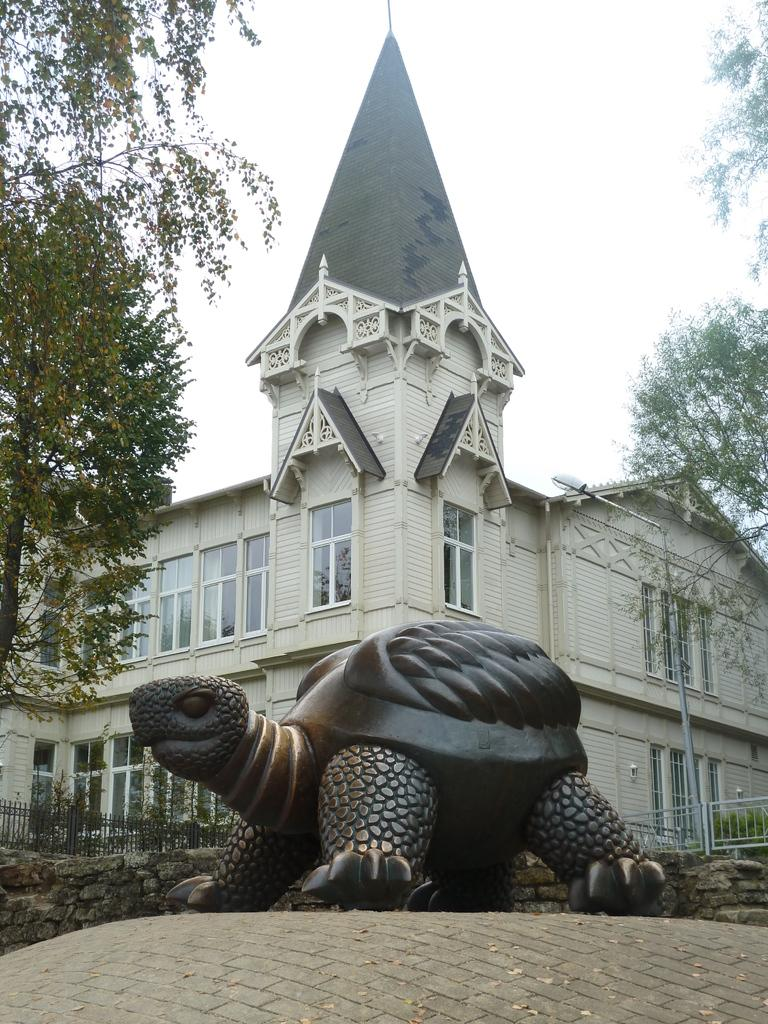What is the main subject in the middle of the image? There is a sculpture in the in the middle of the image. What can be seen in the background of the image? There is a fence, trees, a building, and a pole in the background of the image. Can you describe the fence in the background? The fence is visible in the background of the image. What type of structure is located in the background of the image? There is a building in the background of the image. What else can be seen in the background of the image? There is a pole in the background of the image. How many loaves of bread are being held by the sculpture in the image? There are no loaves of bread present in the image, as the main subject is a sculpture and not related to bread. 